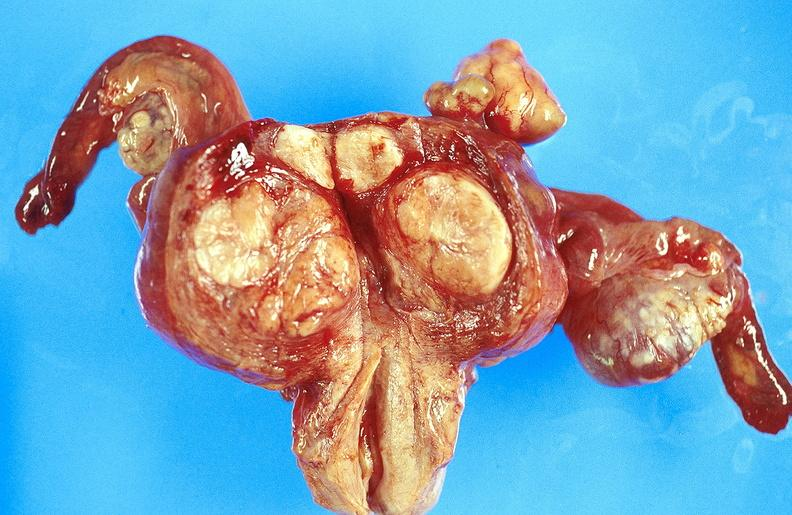what does this image show?
Answer the question using a single word or phrase. Uterus 